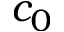Convert formula to latex. <formula><loc_0><loc_0><loc_500><loc_500>c _ { 0 }</formula> 